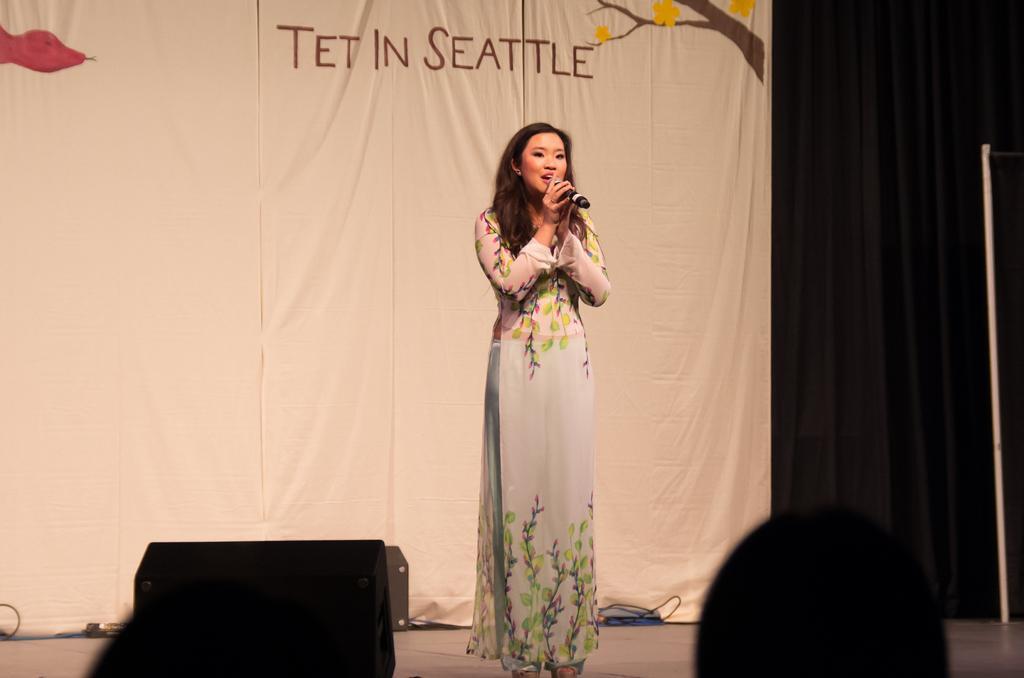Could you give a brief overview of what you see in this image? In this picture I can see a woman is standing on the stage. The woman is holding a microphone in the hand and wearing a white color dress. In the background I can see banner on which something written on it. On the right side I can see black color curtains. 